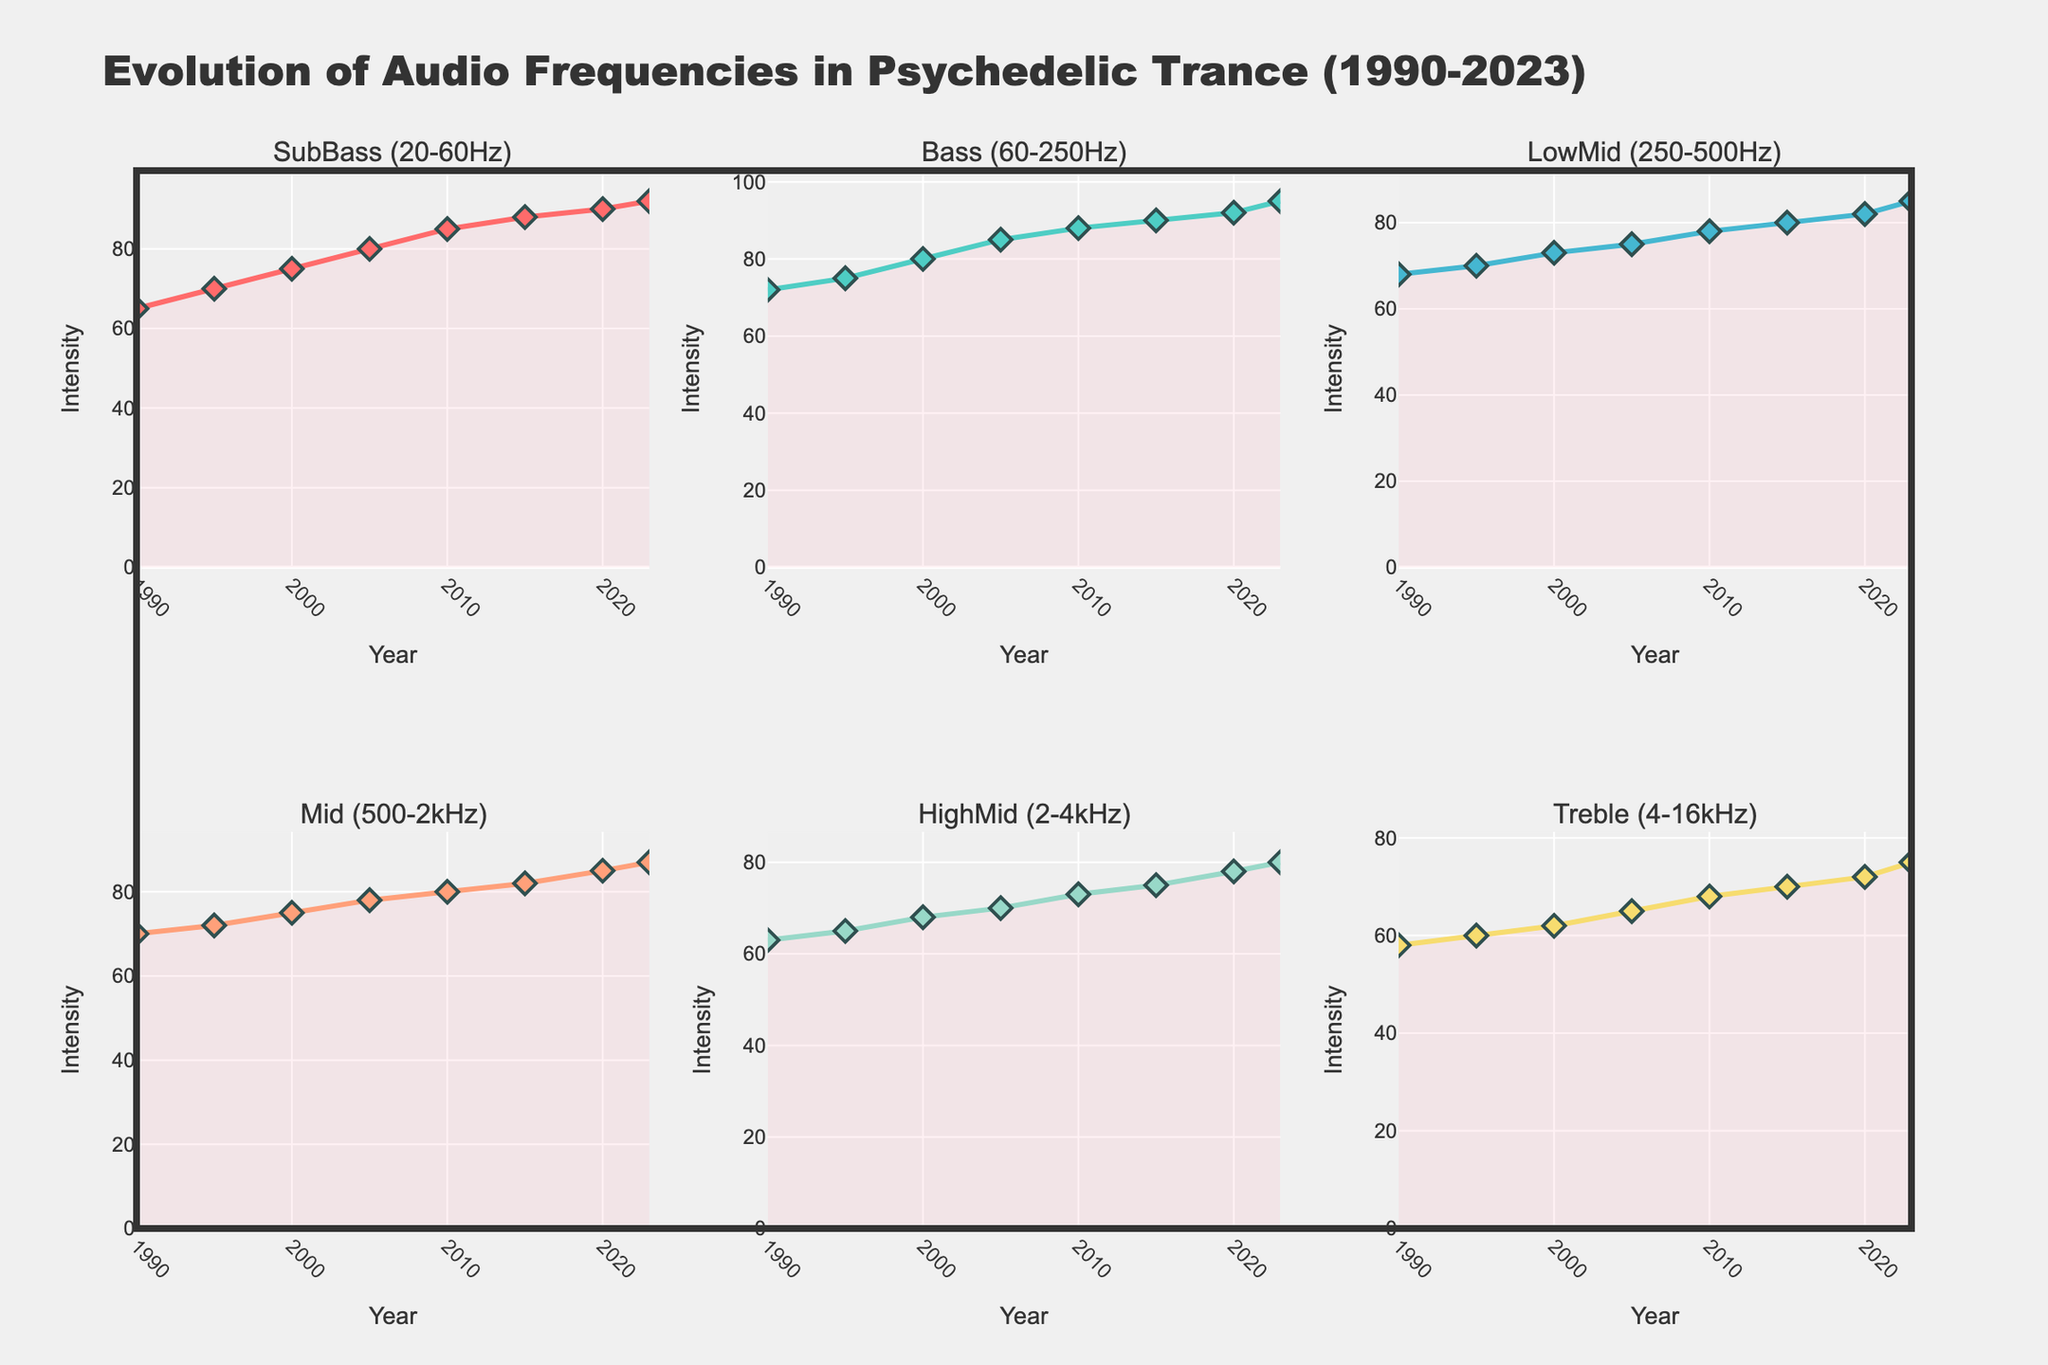What is the title of the figure? The title of the figure is displayed at the top and reads "Evolution of Audio Frequencies in Psychedelic Trance (1990-2023)"
Answer: Evolution of Audio Frequencies in Psychedelic Trance (1990-2023) What are the visualized frequency bands in the subplot titles? The subplot titles list the frequency bands: SubBass (20-60Hz), Bass (60-250Hz), LowMid (250-500Hz), Mid (500-2kHz), HighMid (2-4kHz), and Treble (4-16kHz)
Answer: SubBass, Bass, LowMid, Mid, HighMid, Treble Which frequency band starts at the highest value in 1990? By examining the starting values on the plots for the year 1990, the Bass (60-250Hz) frequency band starts at the highest value, which is 72
Answer: Bass (60-250Hz) In which year did the Treble (4-16kHz) frequency band cross the intensity value of 70? By checking the Treble (4-16kHz) plot, the intensity reaches 70 in the year 2005
Answer: 2005 What is the overall trend observed for the Mid (500-2kHz) frequency band from 1990 to 2023? Observing the line for the Mid (500-2kHz) band, it shows a gradual increase from 1990 to 2023, starting at 70 and ending at 87
Answer: Increasing Which frequency band shows the highest increase in intensity from 1990 to 2023? To find the highest increase, subtract the 1990 value from the 2023 value for each frequency band. The SubBass (20-60Hz) increases the most with a rise from 65 to 92, an increase of 27
Answer: SubBass (20-60Hz) How does the intensity of the HighMid (2-4kHz) in 2010 compare to that in 2000? Checking the values in the HighMid (2-4kHz) plot, the intensity rises from 68 in 2000 to 73 in 2010
Answer: It increased What is the average intensity value for the Bass (60-250Hz) frequency band over the years provided? Adding up the Bass (60-250Hz) values from each year and dividing by the total number of years gives: (72 + 75 + 80 + 85 + 88 + 90 + 92 + 95) / 8 = 84.625
Answer: 84.625 Which frequency band shows the smallest change in intensity between 1995 and 2023? The difference between the values for each band in 1995 and 2023 is examined. LowMid (250-500Hz) shows the smallest change from 70 to 85, an increase of 15
Answer: LowMid (250-500Hz) From which year did the Bass (60-250Hz) frequency band's intensity surpass 85? Looking at the Bass (60-250Hz) plot, the intensity surpasses 85 in the year 2005
Answer: 2005 